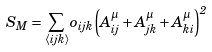Convert formula to latex. <formula><loc_0><loc_0><loc_500><loc_500>S _ { M } = \sum _ { \langle i j k \rangle } o _ { i j k } \left ( A _ { i j } ^ { \mu } + A _ { j k } ^ { \mu } + A _ { k i } ^ { \mu } \right ) ^ { 2 }</formula> 